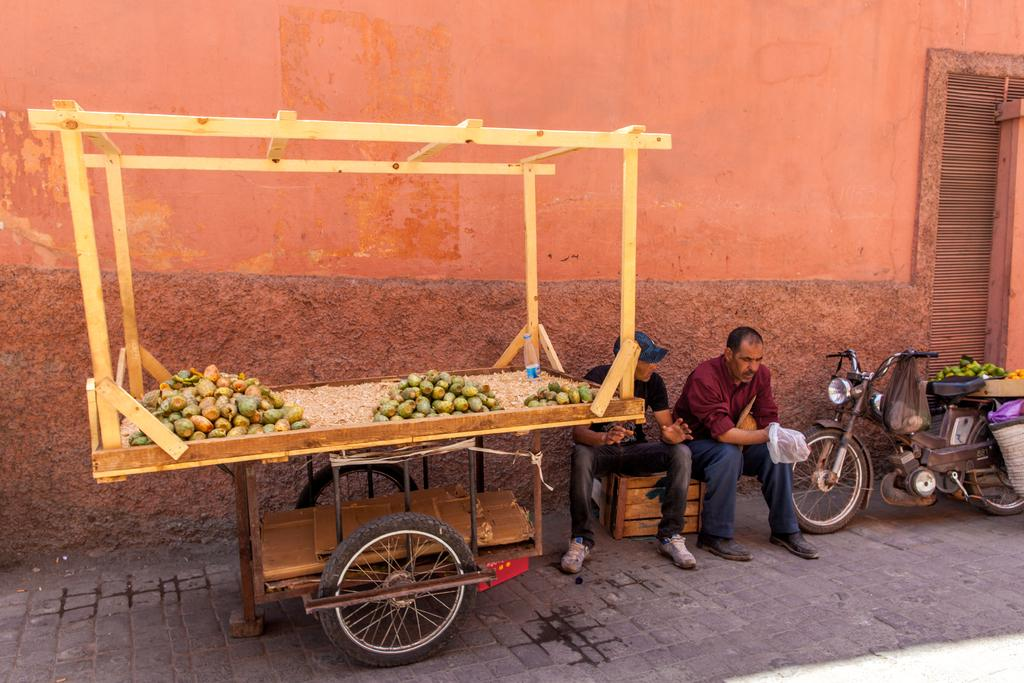What object is in the picture that is used for carrying items? There is a wooden trolley in the picture. What is placed on the wooden trolley? Fruits are placed on the trolley. What vehicle can be seen on the right side of the image? There is a motorcycle on the right side of the image. What is visible in the background of the image? There is a wall in the background of the image. What type of bird is flying over the motorcycle in the image? There is no bird present in the image; it only features a wooden trolley with fruits, a motorcycle, and a wall in the background. 